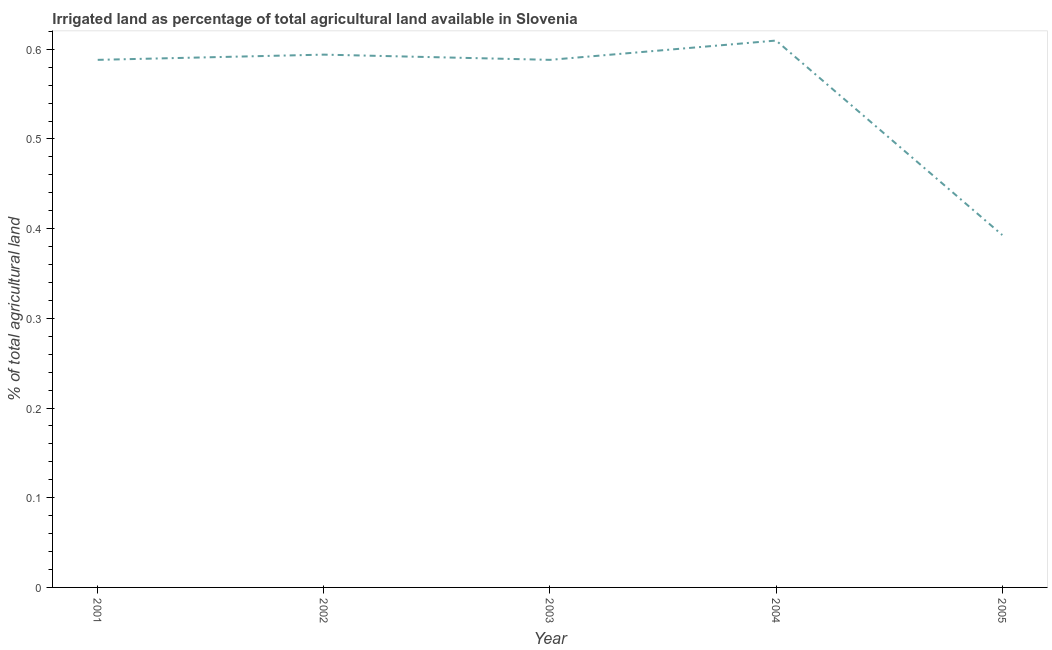What is the percentage of agricultural irrigated land in 2004?
Make the answer very short. 0.61. Across all years, what is the maximum percentage of agricultural irrigated land?
Your answer should be very brief. 0.61. Across all years, what is the minimum percentage of agricultural irrigated land?
Ensure brevity in your answer.  0.39. In which year was the percentage of agricultural irrigated land maximum?
Provide a short and direct response. 2004. In which year was the percentage of agricultural irrigated land minimum?
Keep it short and to the point. 2005. What is the sum of the percentage of agricultural irrigated land?
Your answer should be very brief. 2.77. What is the difference between the percentage of agricultural irrigated land in 2001 and 2005?
Provide a succinct answer. 0.2. What is the average percentage of agricultural irrigated land per year?
Keep it short and to the point. 0.55. What is the median percentage of agricultural irrigated land?
Offer a terse response. 0.59. In how many years, is the percentage of agricultural irrigated land greater than 0.5 %?
Offer a terse response. 4. Do a majority of the years between 2001 and 2005 (inclusive) have percentage of agricultural irrigated land greater than 0.18 %?
Ensure brevity in your answer.  Yes. What is the ratio of the percentage of agricultural irrigated land in 2002 to that in 2004?
Provide a succinct answer. 0.97. What is the difference between the highest and the second highest percentage of agricultural irrigated land?
Provide a short and direct response. 0.02. What is the difference between the highest and the lowest percentage of agricultural irrigated land?
Offer a very short reply. 0.22. Does the percentage of agricultural irrigated land monotonically increase over the years?
Provide a short and direct response. No. How many years are there in the graph?
Keep it short and to the point. 5. What is the difference between two consecutive major ticks on the Y-axis?
Your answer should be compact. 0.1. What is the title of the graph?
Your response must be concise. Irrigated land as percentage of total agricultural land available in Slovenia. What is the label or title of the Y-axis?
Provide a succinct answer. % of total agricultural land. What is the % of total agricultural land in 2001?
Make the answer very short. 0.59. What is the % of total agricultural land of 2002?
Offer a terse response. 0.59. What is the % of total agricultural land of 2003?
Your response must be concise. 0.59. What is the % of total agricultural land in 2004?
Provide a succinct answer. 0.61. What is the % of total agricultural land in 2005?
Make the answer very short. 0.39. What is the difference between the % of total agricultural land in 2001 and 2002?
Your answer should be compact. -0.01. What is the difference between the % of total agricultural land in 2001 and 2004?
Give a very brief answer. -0.02. What is the difference between the % of total agricultural land in 2001 and 2005?
Keep it short and to the point. 0.2. What is the difference between the % of total agricultural land in 2002 and 2003?
Offer a terse response. 0.01. What is the difference between the % of total agricultural land in 2002 and 2004?
Provide a short and direct response. -0.02. What is the difference between the % of total agricultural land in 2002 and 2005?
Keep it short and to the point. 0.2. What is the difference between the % of total agricultural land in 2003 and 2004?
Offer a very short reply. -0.02. What is the difference between the % of total agricultural land in 2003 and 2005?
Provide a succinct answer. 0.2. What is the difference between the % of total agricultural land in 2004 and 2005?
Keep it short and to the point. 0.22. What is the ratio of the % of total agricultural land in 2001 to that in 2005?
Keep it short and to the point. 1.5. What is the ratio of the % of total agricultural land in 2002 to that in 2004?
Keep it short and to the point. 0.97. What is the ratio of the % of total agricultural land in 2002 to that in 2005?
Give a very brief answer. 1.51. What is the ratio of the % of total agricultural land in 2003 to that in 2005?
Provide a succinct answer. 1.5. What is the ratio of the % of total agricultural land in 2004 to that in 2005?
Keep it short and to the point. 1.55. 